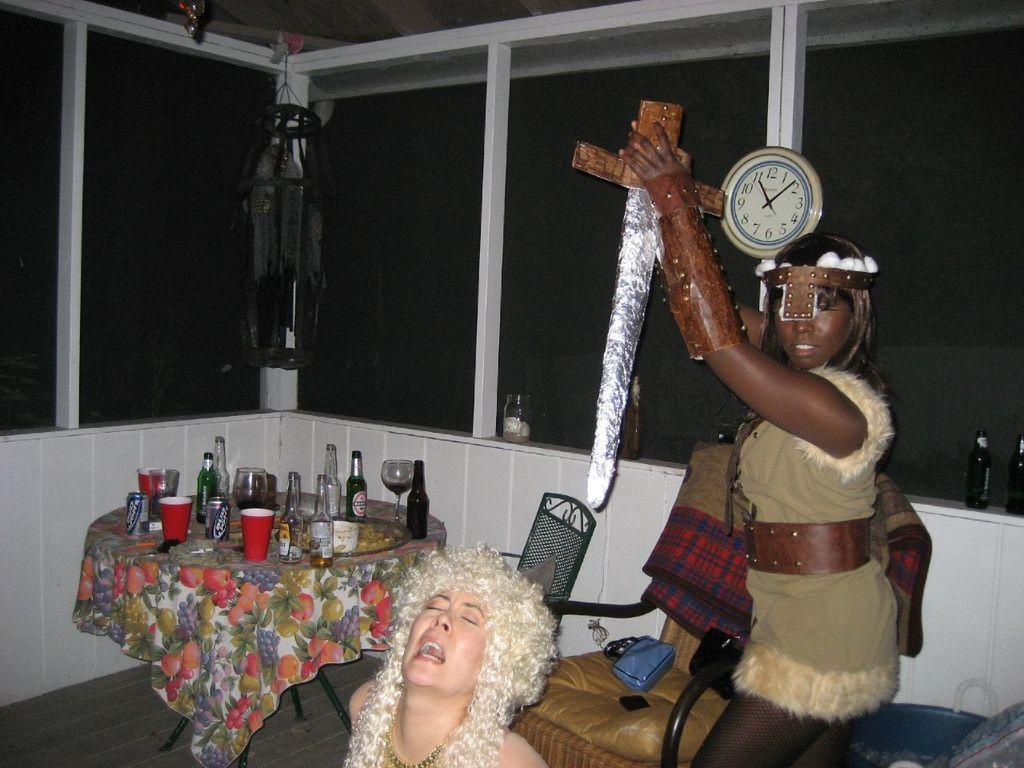<image>
Offer a succinct explanation of the picture presented. Women in costumes next to a table with empty cans of Bud Light on it. 